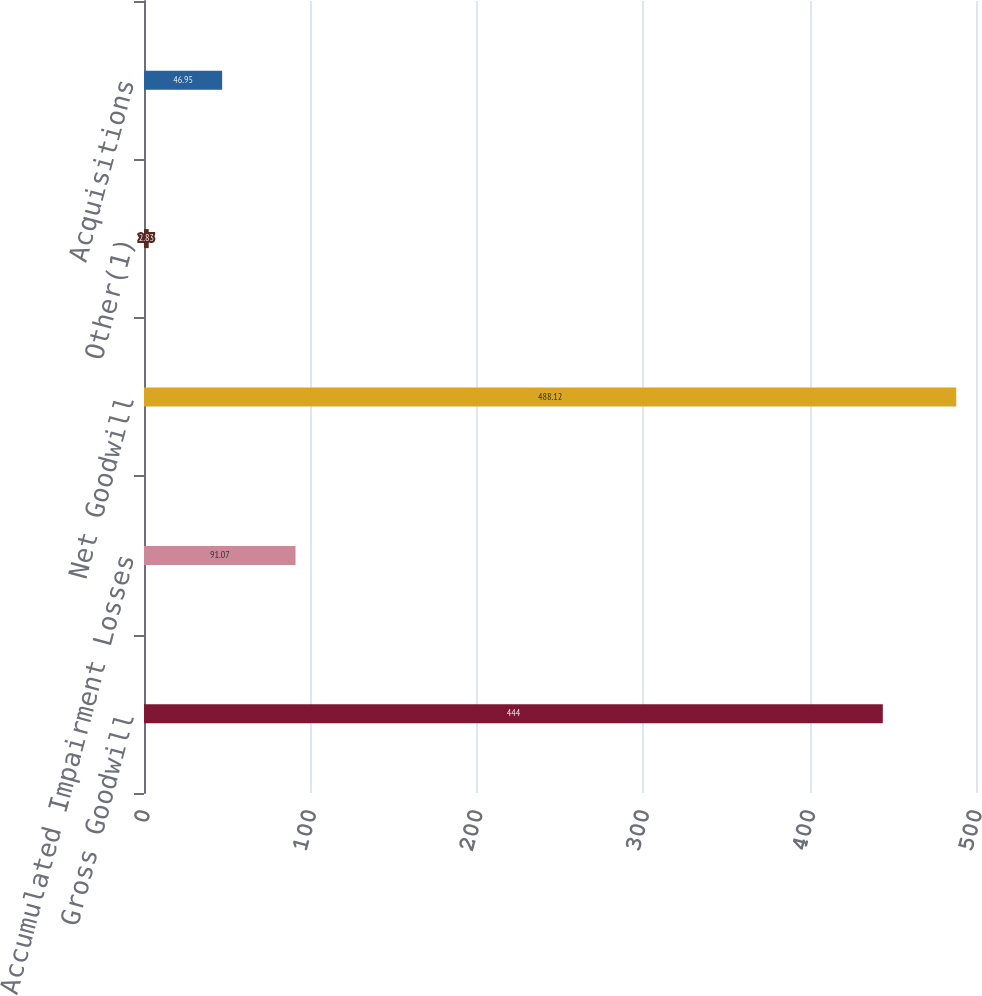<chart> <loc_0><loc_0><loc_500><loc_500><bar_chart><fcel>Gross Goodwill<fcel>Accumulated Impairment Losses<fcel>Net Goodwill<fcel>Other(1)<fcel>Acquisitions<nl><fcel>444<fcel>91.07<fcel>488.12<fcel>2.83<fcel>46.95<nl></chart> 